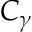Convert formula to latex. <formula><loc_0><loc_0><loc_500><loc_500>C _ { \gamma }</formula> 